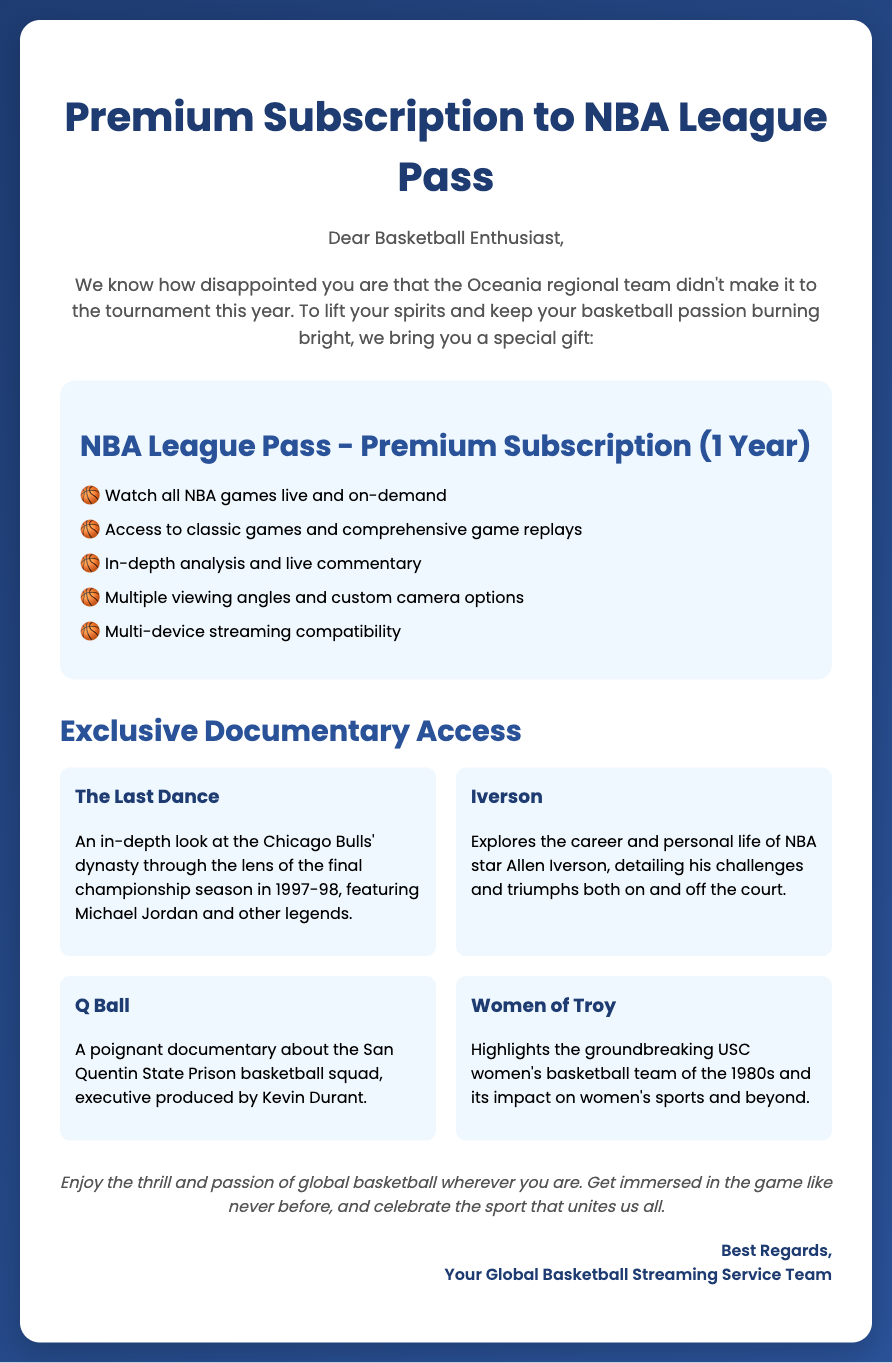What is the title of the gift voucher? The title is prominently displayed at the top of the voucher.
Answer: Premium Subscription to NBA League Pass How long is the premium subscription valid? The duration of the subscription is mentioned in the section of the document about the premium subscription.
Answer: 1 Year Which documentary focuses on the Chicago Bulls? The document lists various documentaries, and one specifically details the Chicago Bulls' dynasty.
Answer: The Last Dance What is the first item listed under the subscription benefits? The order of items in the subscription benefits section is relevant for identifying them.
Answer: Watch all NBA games live and on-demand Who produced the documentary about the San Quentin State Prison basketball squad? The document attributes the executive production of the documentary to a specific individual.
Answer: Kevin Durant What is the main theme of "Iverson" documentary? This question pertains to the subject matter highlighted in the documentary description within the voucher.
Answer: Career and personal life of Allen Iverson How many documentaries are listed in the voucher? Observing the documentaries' section will reveal the total number listed.
Answer: 4 Is there a documentary that highlights women's basketball? This question addresses the representation of women's basketball in the document's information.
Answer: Yes What is the color scheme of the voucher's background? The background is described in the style section of the document.
Answer: Gradient of deep blue shades 